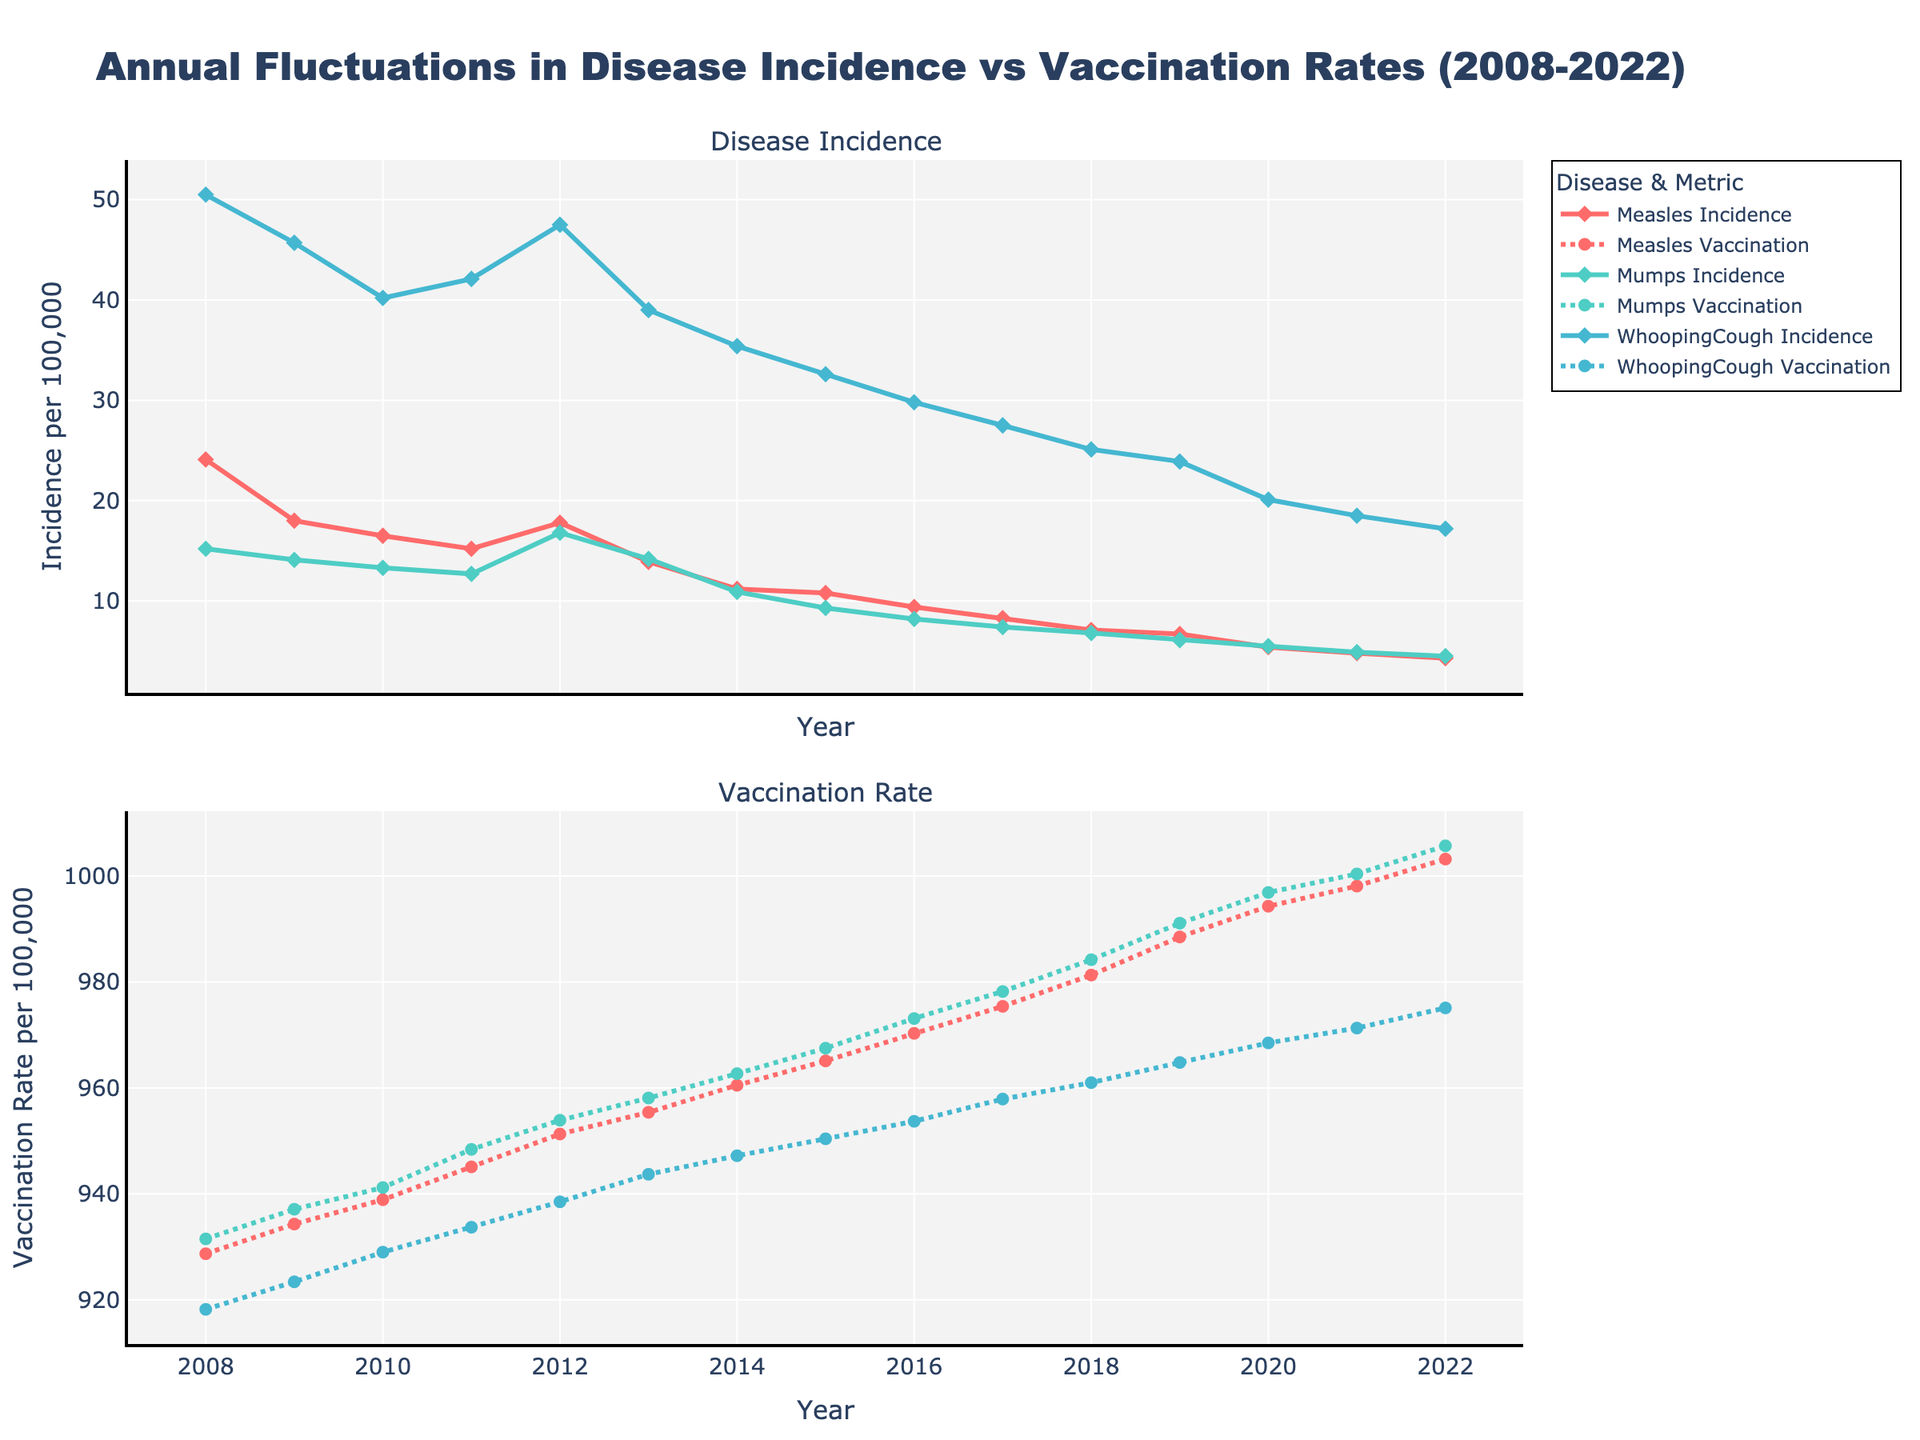What is the overall trend in measles incidence from 2008 to 2022? The incidence of measles shows a decreasing trend over the years. In 2008, it starts at 24.1 per 100,000 and gradually declines to 4.3 per 100,000 by 2022.
Answer: Decreasing Which year had the highest vaccination rate for mumps? By observing the vaccination rates over the years, it can be seen that 2022 has the highest vaccination rate for mumps at 1005.7 per 100,000.
Answer: 2022 Compare the incidence of whooping cough in 2008 and 2022. Which year had a higher incidence? By examining the incidence rates, the value in 2008 was 50.5 per 100,000, while it is 17.2 per 100,000 in 2022. 2008 had a higher incidence.
Answer: 2008 How did the vaccination rate for measles change from 2018 to 2020? The vaccination rate for measles increased from 981.3 per 100,000 in 2018 to 994.3 per 100,000 in 2020.
Answer: Increased What is the difference in mumps incidence between 2009 and 2021? The mumps incidence in 2009 was 14.1 per 100,000 and dropped to 4.9 per 100,000 in 2021. Therefore, the difference is 14.1 - 4.9 = 9.2 per 100,000.
Answer: 9.2 What general trend can be observed when comparing the vaccination rates and the incidence of the diseases? An inverse relationship is observed; as vaccination rates increase, the incidence of diseases tends to decrease.
Answer: Inverse relationship Which disease had the lowest incidence in 2021? By looking at the incidence rates in 2021, measles has the lowest at 4.8 per 100,000.
Answer: Measles On average, how has the vaccination rate for whooping cough changed from 2008 to 2022? The vaccination rate for whooping cough in 2008 was 918.2 per 100,000, and it increased to 975.1 per 100,000 in 2022. The average change over these years can be calculated: (975.1 - 918.2) / (2022 - 2008) = 3.986 per year.
Answer: Approximately 3.99 per year How does the incidence of mumps in 2015 compare to the incidence of measles in the same year? In 2015, the mumps incidence was 9.3 per 100,000, and the measles incidence was 10.8 per 100,000. Measles incidence is higher.
Answer: Measles is higher Describe the trend in whooping cough incidence from 2008 to 2022. The incidence of whooping cough shows a general decreasing trend from 50.5 per 100,000 in 2008 to 17.2 per 100,000 in 2022, despite some small fluctuations.
Answer: Decreasing 